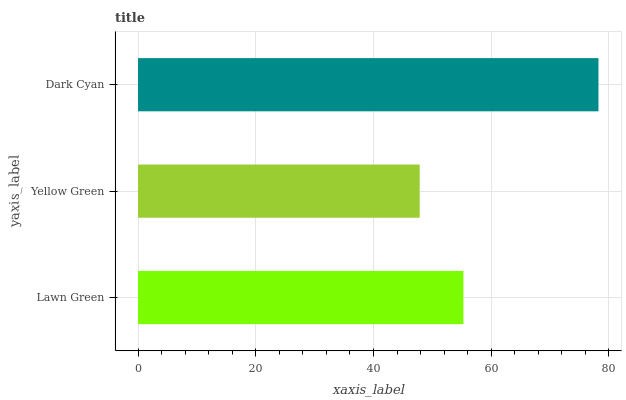Is Yellow Green the minimum?
Answer yes or no. Yes. Is Dark Cyan the maximum?
Answer yes or no. Yes. Is Dark Cyan the minimum?
Answer yes or no. No. Is Yellow Green the maximum?
Answer yes or no. No. Is Dark Cyan greater than Yellow Green?
Answer yes or no. Yes. Is Yellow Green less than Dark Cyan?
Answer yes or no. Yes. Is Yellow Green greater than Dark Cyan?
Answer yes or no. No. Is Dark Cyan less than Yellow Green?
Answer yes or no. No. Is Lawn Green the high median?
Answer yes or no. Yes. Is Lawn Green the low median?
Answer yes or no. Yes. Is Yellow Green the high median?
Answer yes or no. No. Is Dark Cyan the low median?
Answer yes or no. No. 